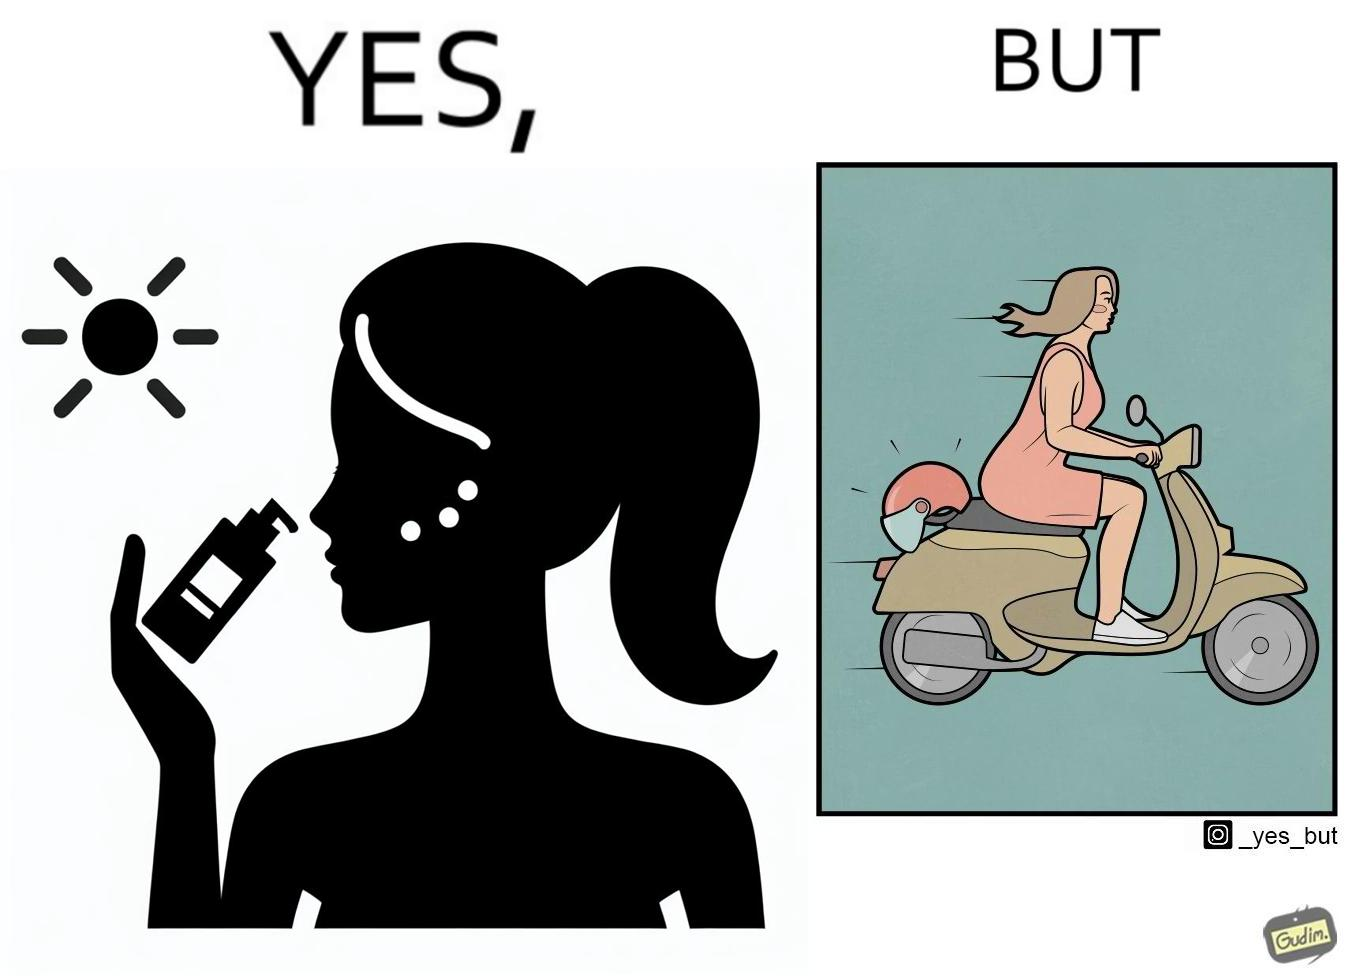Explain the humor or irony in this image. The image is funny because while the woman is concerned about protection from the sun rays, she is not concerned about her safety while riding a scooter. 